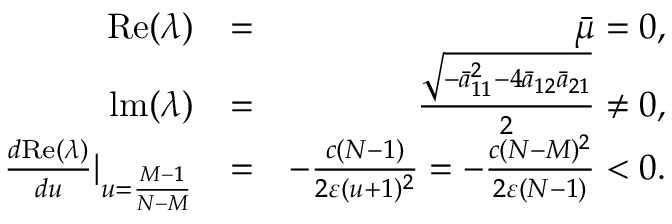Convert formula to latex. <formula><loc_0><loc_0><loc_500><loc_500>\begin{array} { r l r } { R e ( \lambda ) } & { = } & { \bar { \mu } = 0 , } \\ { l m ( \lambda ) } & { = } & { \frac { \sqrt { - \bar { a } _ { 1 1 } ^ { 2 } - 4 \bar { a } _ { 1 2 } \bar { a } _ { 2 1 } } } { 2 } \neq 0 , } \\ { \frac { d R e ( \lambda ) } { d u } | _ { u = \frac { M - 1 } { N - M } } } & { = } & { - \frac { c ( N - 1 ) } { 2 \varepsilon ( u + 1 ) ^ { 2 } } = - \frac { c ( N - M ) ^ { 2 } } { 2 \varepsilon ( N - 1 ) } < 0 . } \end{array}</formula> 